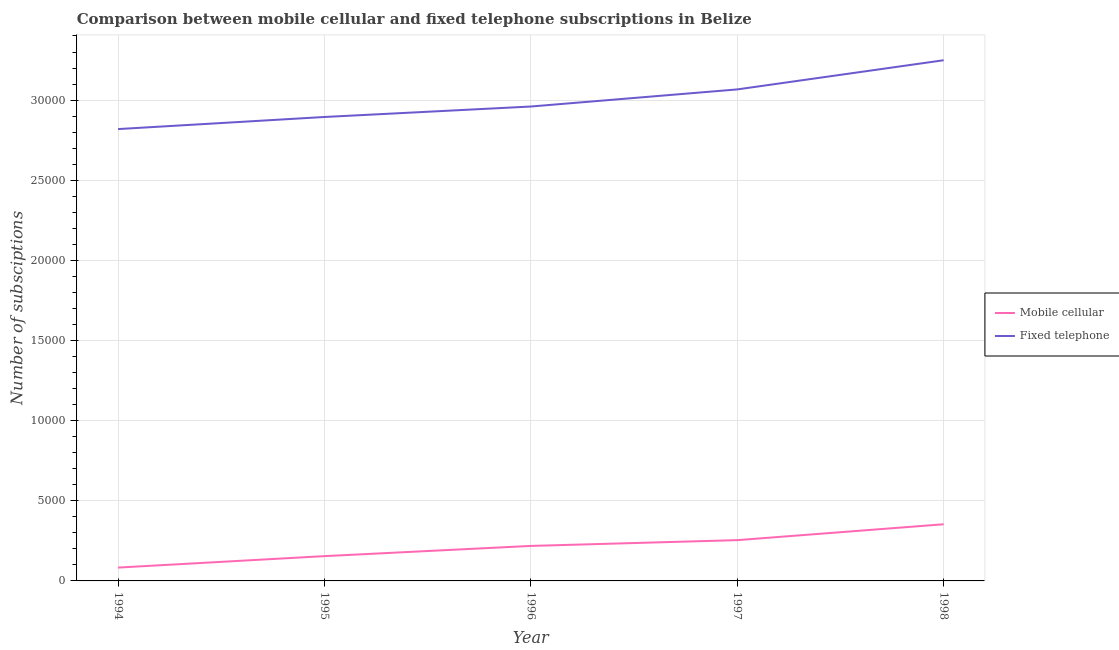Is the number of lines equal to the number of legend labels?
Provide a succinct answer. Yes. What is the number of mobile cellular subscriptions in 1997?
Ensure brevity in your answer.  2544. Across all years, what is the maximum number of fixed telephone subscriptions?
Ensure brevity in your answer.  3.25e+04. Across all years, what is the minimum number of mobile cellular subscriptions?
Provide a succinct answer. 832. In which year was the number of mobile cellular subscriptions minimum?
Your response must be concise. 1994. What is the total number of mobile cellular subscriptions in the graph?
Give a very brief answer. 1.06e+04. What is the difference between the number of mobile cellular subscriptions in 1995 and that in 1996?
Your answer should be compact. -637. What is the difference between the number of fixed telephone subscriptions in 1996 and the number of mobile cellular subscriptions in 1995?
Your response must be concise. 2.81e+04. What is the average number of mobile cellular subscriptions per year?
Ensure brevity in your answer.  2128.4. In the year 1995, what is the difference between the number of fixed telephone subscriptions and number of mobile cellular subscriptions?
Offer a very short reply. 2.74e+04. In how many years, is the number of mobile cellular subscriptions greater than 15000?
Keep it short and to the point. 0. What is the ratio of the number of fixed telephone subscriptions in 1994 to that in 1997?
Offer a terse response. 0.92. Is the difference between the number of mobile cellular subscriptions in 1996 and 1998 greater than the difference between the number of fixed telephone subscriptions in 1996 and 1998?
Offer a terse response. Yes. What is the difference between the highest and the second highest number of mobile cellular subscriptions?
Your response must be concise. 991. What is the difference between the highest and the lowest number of mobile cellular subscriptions?
Ensure brevity in your answer.  2703. In how many years, is the number of fixed telephone subscriptions greater than the average number of fixed telephone subscriptions taken over all years?
Your answer should be very brief. 2. Does the number of fixed telephone subscriptions monotonically increase over the years?
Provide a succinct answer. Yes. Is the number of mobile cellular subscriptions strictly greater than the number of fixed telephone subscriptions over the years?
Keep it short and to the point. No. Is the number of mobile cellular subscriptions strictly less than the number of fixed telephone subscriptions over the years?
Give a very brief answer. Yes. How many years are there in the graph?
Keep it short and to the point. 5. Are the values on the major ticks of Y-axis written in scientific E-notation?
Offer a terse response. No. Where does the legend appear in the graph?
Give a very brief answer. Center right. What is the title of the graph?
Make the answer very short. Comparison between mobile cellular and fixed telephone subscriptions in Belize. What is the label or title of the X-axis?
Provide a succinct answer. Year. What is the label or title of the Y-axis?
Offer a terse response. Number of subsciptions. What is the Number of subsciptions of Mobile cellular in 1994?
Offer a very short reply. 832. What is the Number of subsciptions of Fixed telephone in 1994?
Ensure brevity in your answer.  2.82e+04. What is the Number of subsciptions of Mobile cellular in 1995?
Your answer should be very brief. 1547. What is the Number of subsciptions of Fixed telephone in 1995?
Offer a very short reply. 2.89e+04. What is the Number of subsciptions of Mobile cellular in 1996?
Offer a terse response. 2184. What is the Number of subsciptions in Fixed telephone in 1996?
Make the answer very short. 2.96e+04. What is the Number of subsciptions in Mobile cellular in 1997?
Make the answer very short. 2544. What is the Number of subsciptions of Fixed telephone in 1997?
Your response must be concise. 3.07e+04. What is the Number of subsciptions in Mobile cellular in 1998?
Ensure brevity in your answer.  3535. What is the Number of subsciptions of Fixed telephone in 1998?
Keep it short and to the point. 3.25e+04. Across all years, what is the maximum Number of subsciptions in Mobile cellular?
Ensure brevity in your answer.  3535. Across all years, what is the maximum Number of subsciptions in Fixed telephone?
Your response must be concise. 3.25e+04. Across all years, what is the minimum Number of subsciptions of Mobile cellular?
Ensure brevity in your answer.  832. Across all years, what is the minimum Number of subsciptions in Fixed telephone?
Your answer should be very brief. 2.82e+04. What is the total Number of subsciptions in Mobile cellular in the graph?
Keep it short and to the point. 1.06e+04. What is the total Number of subsciptions in Fixed telephone in the graph?
Ensure brevity in your answer.  1.50e+05. What is the difference between the Number of subsciptions in Mobile cellular in 1994 and that in 1995?
Your answer should be compact. -715. What is the difference between the Number of subsciptions of Fixed telephone in 1994 and that in 1995?
Offer a very short reply. -755. What is the difference between the Number of subsciptions of Mobile cellular in 1994 and that in 1996?
Give a very brief answer. -1352. What is the difference between the Number of subsciptions in Fixed telephone in 1994 and that in 1996?
Offer a terse response. -1408. What is the difference between the Number of subsciptions of Mobile cellular in 1994 and that in 1997?
Offer a very short reply. -1712. What is the difference between the Number of subsciptions in Fixed telephone in 1994 and that in 1997?
Offer a terse response. -2475. What is the difference between the Number of subsciptions of Mobile cellular in 1994 and that in 1998?
Make the answer very short. -2703. What is the difference between the Number of subsciptions of Fixed telephone in 1994 and that in 1998?
Your response must be concise. -4295. What is the difference between the Number of subsciptions in Mobile cellular in 1995 and that in 1996?
Your response must be concise. -637. What is the difference between the Number of subsciptions of Fixed telephone in 1995 and that in 1996?
Offer a terse response. -653. What is the difference between the Number of subsciptions in Mobile cellular in 1995 and that in 1997?
Provide a succinct answer. -997. What is the difference between the Number of subsciptions in Fixed telephone in 1995 and that in 1997?
Give a very brief answer. -1720. What is the difference between the Number of subsciptions of Mobile cellular in 1995 and that in 1998?
Offer a very short reply. -1988. What is the difference between the Number of subsciptions in Fixed telephone in 1995 and that in 1998?
Give a very brief answer. -3540. What is the difference between the Number of subsciptions of Mobile cellular in 1996 and that in 1997?
Keep it short and to the point. -360. What is the difference between the Number of subsciptions in Fixed telephone in 1996 and that in 1997?
Offer a very short reply. -1067. What is the difference between the Number of subsciptions of Mobile cellular in 1996 and that in 1998?
Your answer should be compact. -1351. What is the difference between the Number of subsciptions in Fixed telephone in 1996 and that in 1998?
Ensure brevity in your answer.  -2887. What is the difference between the Number of subsciptions in Mobile cellular in 1997 and that in 1998?
Make the answer very short. -991. What is the difference between the Number of subsciptions of Fixed telephone in 1997 and that in 1998?
Provide a short and direct response. -1820. What is the difference between the Number of subsciptions of Mobile cellular in 1994 and the Number of subsciptions of Fixed telephone in 1995?
Your answer should be very brief. -2.81e+04. What is the difference between the Number of subsciptions of Mobile cellular in 1994 and the Number of subsciptions of Fixed telephone in 1996?
Provide a short and direct response. -2.88e+04. What is the difference between the Number of subsciptions of Mobile cellular in 1994 and the Number of subsciptions of Fixed telephone in 1997?
Make the answer very short. -2.98e+04. What is the difference between the Number of subsciptions in Mobile cellular in 1994 and the Number of subsciptions in Fixed telephone in 1998?
Make the answer very short. -3.17e+04. What is the difference between the Number of subsciptions in Mobile cellular in 1995 and the Number of subsciptions in Fixed telephone in 1996?
Give a very brief answer. -2.81e+04. What is the difference between the Number of subsciptions of Mobile cellular in 1995 and the Number of subsciptions of Fixed telephone in 1997?
Offer a terse response. -2.91e+04. What is the difference between the Number of subsciptions of Mobile cellular in 1995 and the Number of subsciptions of Fixed telephone in 1998?
Offer a very short reply. -3.09e+04. What is the difference between the Number of subsciptions in Mobile cellular in 1996 and the Number of subsciptions in Fixed telephone in 1997?
Ensure brevity in your answer.  -2.85e+04. What is the difference between the Number of subsciptions in Mobile cellular in 1996 and the Number of subsciptions in Fixed telephone in 1998?
Provide a short and direct response. -3.03e+04. What is the difference between the Number of subsciptions of Mobile cellular in 1997 and the Number of subsciptions of Fixed telephone in 1998?
Offer a terse response. -2.99e+04. What is the average Number of subsciptions of Mobile cellular per year?
Provide a succinct answer. 2128.4. What is the average Number of subsciptions in Fixed telephone per year?
Make the answer very short. 3.00e+04. In the year 1994, what is the difference between the Number of subsciptions of Mobile cellular and Number of subsciptions of Fixed telephone?
Keep it short and to the point. -2.74e+04. In the year 1995, what is the difference between the Number of subsciptions of Mobile cellular and Number of subsciptions of Fixed telephone?
Make the answer very short. -2.74e+04. In the year 1996, what is the difference between the Number of subsciptions in Mobile cellular and Number of subsciptions in Fixed telephone?
Your answer should be compact. -2.74e+04. In the year 1997, what is the difference between the Number of subsciptions in Mobile cellular and Number of subsciptions in Fixed telephone?
Offer a very short reply. -2.81e+04. In the year 1998, what is the difference between the Number of subsciptions of Mobile cellular and Number of subsciptions of Fixed telephone?
Give a very brief answer. -2.90e+04. What is the ratio of the Number of subsciptions in Mobile cellular in 1994 to that in 1995?
Offer a very short reply. 0.54. What is the ratio of the Number of subsciptions in Fixed telephone in 1994 to that in 1995?
Your response must be concise. 0.97. What is the ratio of the Number of subsciptions in Mobile cellular in 1994 to that in 1996?
Your response must be concise. 0.38. What is the ratio of the Number of subsciptions of Mobile cellular in 1994 to that in 1997?
Your response must be concise. 0.33. What is the ratio of the Number of subsciptions of Fixed telephone in 1994 to that in 1997?
Keep it short and to the point. 0.92. What is the ratio of the Number of subsciptions in Mobile cellular in 1994 to that in 1998?
Your answer should be very brief. 0.24. What is the ratio of the Number of subsciptions of Fixed telephone in 1994 to that in 1998?
Ensure brevity in your answer.  0.87. What is the ratio of the Number of subsciptions of Mobile cellular in 1995 to that in 1996?
Provide a succinct answer. 0.71. What is the ratio of the Number of subsciptions in Fixed telephone in 1995 to that in 1996?
Provide a succinct answer. 0.98. What is the ratio of the Number of subsciptions in Mobile cellular in 1995 to that in 1997?
Keep it short and to the point. 0.61. What is the ratio of the Number of subsciptions in Fixed telephone in 1995 to that in 1997?
Make the answer very short. 0.94. What is the ratio of the Number of subsciptions in Mobile cellular in 1995 to that in 1998?
Give a very brief answer. 0.44. What is the ratio of the Number of subsciptions of Fixed telephone in 1995 to that in 1998?
Give a very brief answer. 0.89. What is the ratio of the Number of subsciptions of Mobile cellular in 1996 to that in 1997?
Make the answer very short. 0.86. What is the ratio of the Number of subsciptions of Fixed telephone in 1996 to that in 1997?
Provide a short and direct response. 0.97. What is the ratio of the Number of subsciptions in Mobile cellular in 1996 to that in 1998?
Provide a short and direct response. 0.62. What is the ratio of the Number of subsciptions of Fixed telephone in 1996 to that in 1998?
Provide a short and direct response. 0.91. What is the ratio of the Number of subsciptions in Mobile cellular in 1997 to that in 1998?
Provide a short and direct response. 0.72. What is the ratio of the Number of subsciptions in Fixed telephone in 1997 to that in 1998?
Provide a short and direct response. 0.94. What is the difference between the highest and the second highest Number of subsciptions of Mobile cellular?
Your answer should be very brief. 991. What is the difference between the highest and the second highest Number of subsciptions in Fixed telephone?
Give a very brief answer. 1820. What is the difference between the highest and the lowest Number of subsciptions in Mobile cellular?
Offer a terse response. 2703. What is the difference between the highest and the lowest Number of subsciptions in Fixed telephone?
Keep it short and to the point. 4295. 